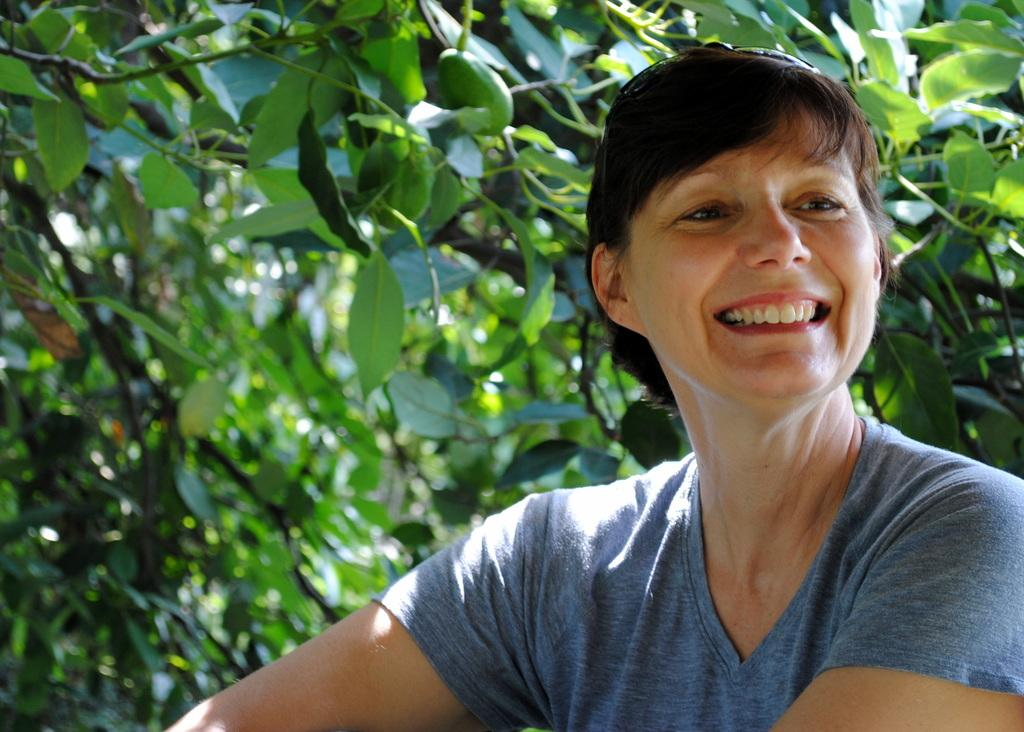What is the main subject of the image? The main subject of the image is a woman. What is the woman doing in the image? The woman is smiling in the image. What type of vegetation can be seen in the background of the image? There are green leaves in the background of the image. What else can be seen in the background of the image? There are stems in the background of the image. What type of canvas is visible in the image? There is no canvas present in the image. Can you see any ducks swimming in the background of the image? There are no ducks visible in the image. 